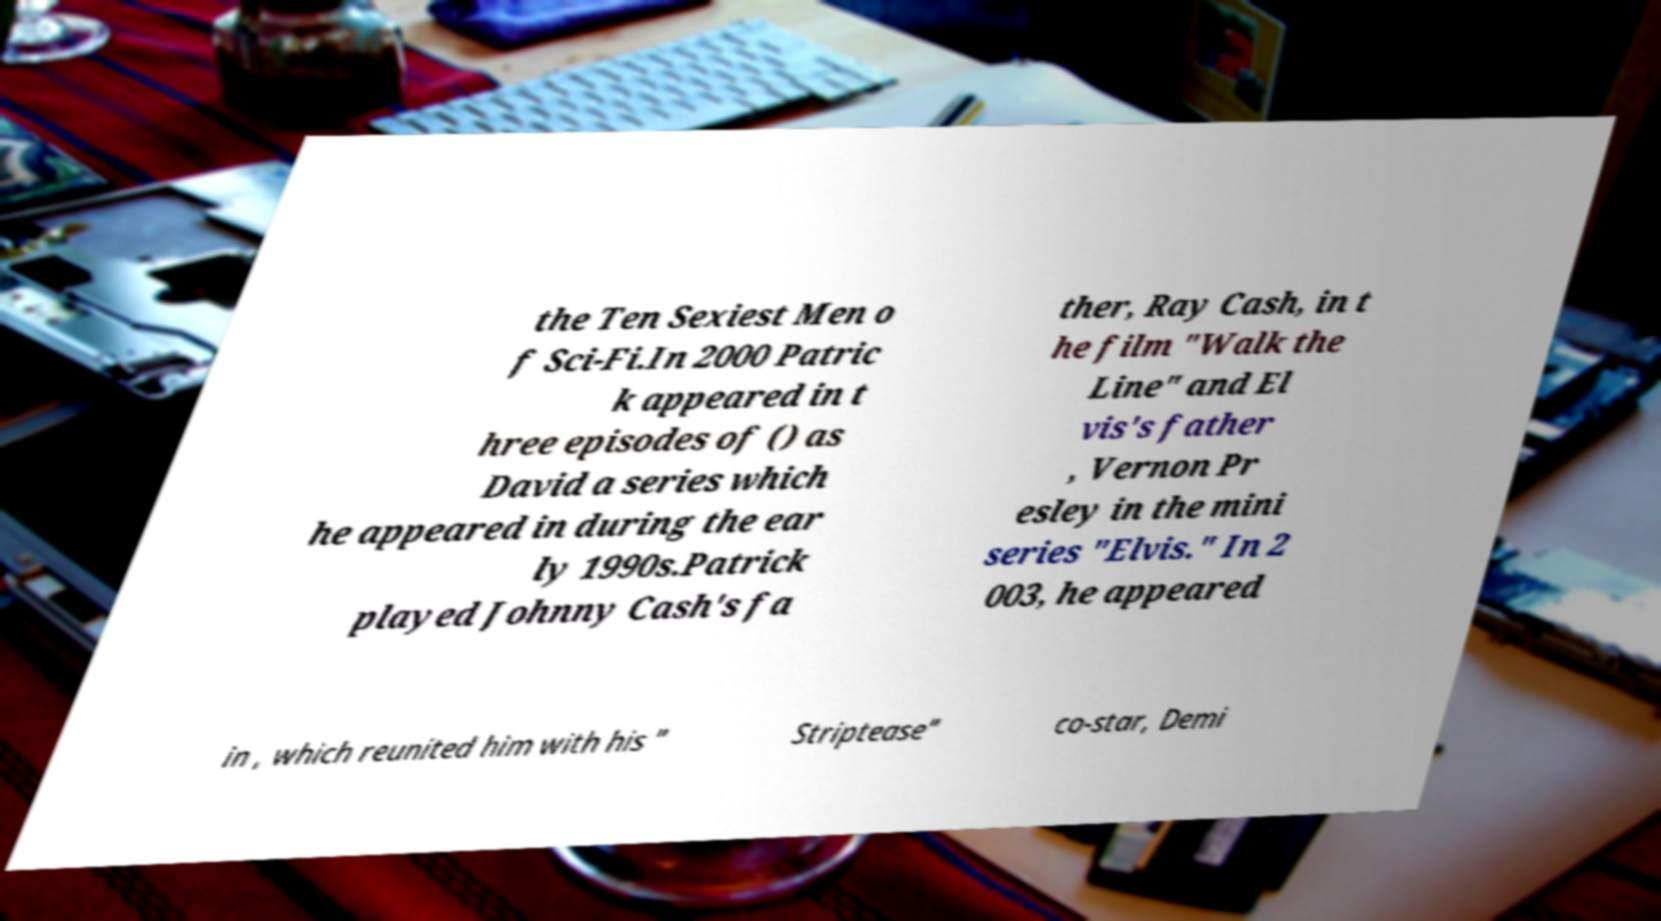Please read and relay the text visible in this image. What does it say? the Ten Sexiest Men o f Sci-Fi.In 2000 Patric k appeared in t hree episodes of () as David a series which he appeared in during the ear ly 1990s.Patrick played Johnny Cash's fa ther, Ray Cash, in t he film "Walk the Line" and El vis's father , Vernon Pr esley in the mini series "Elvis." In 2 003, he appeared in , which reunited him with his " Striptease" co-star, Demi 